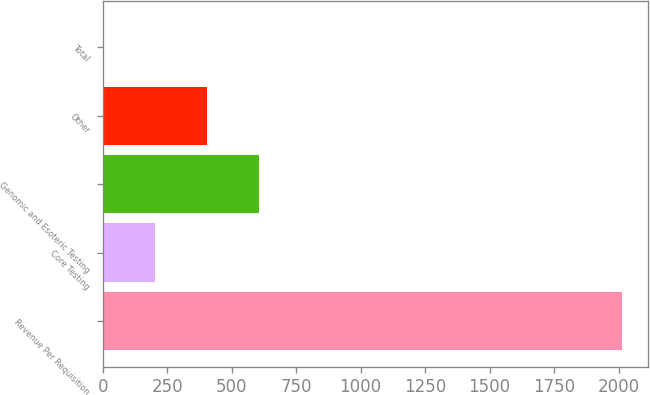Convert chart. <chart><loc_0><loc_0><loc_500><loc_500><bar_chart><fcel>Revenue Per Requisition<fcel>Core Testing<fcel>Genomic and Esoteric Testing<fcel>Other<fcel>Total<nl><fcel>2013<fcel>202.74<fcel>605.02<fcel>403.88<fcel>1.6<nl></chart> 